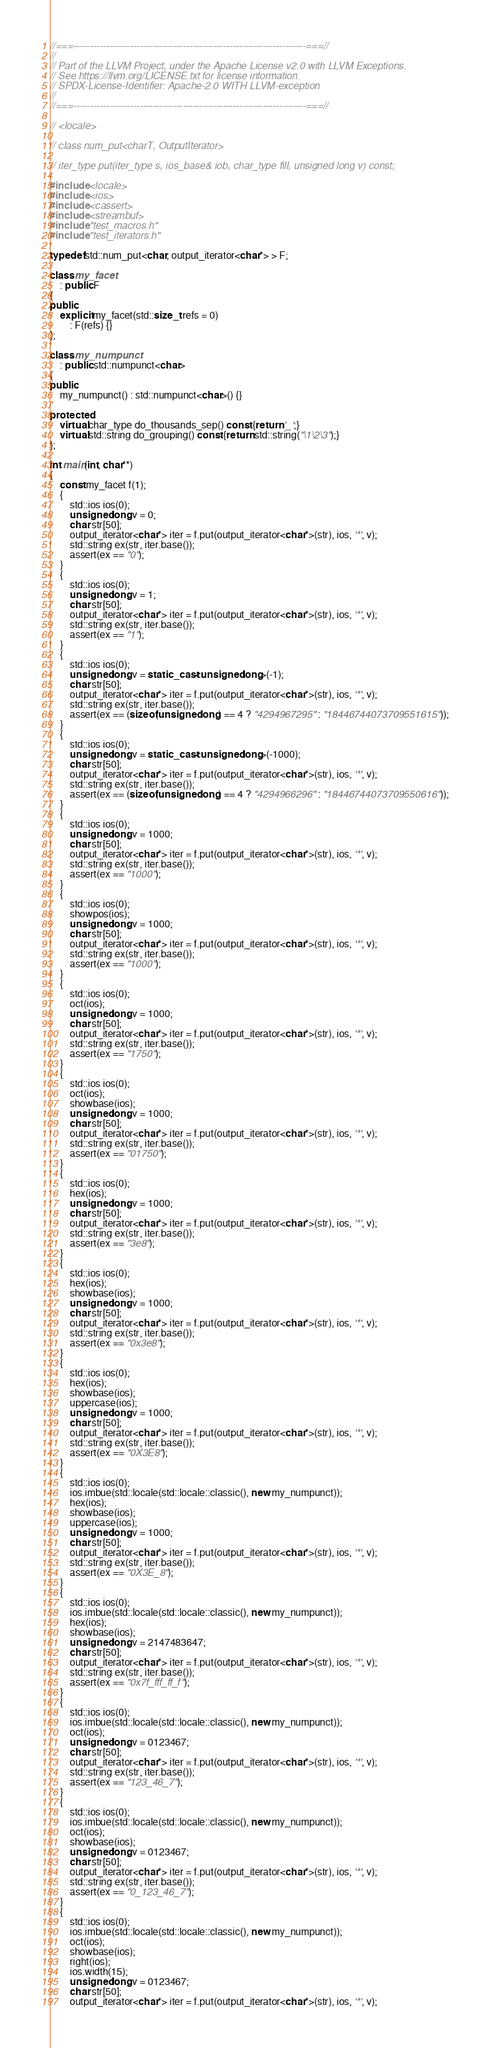<code> <loc_0><loc_0><loc_500><loc_500><_C++_>//===----------------------------------------------------------------------===//
//
// Part of the LLVM Project, under the Apache License v2.0 with LLVM Exceptions.
// See https://llvm.org/LICENSE.txt for license information.
// SPDX-License-Identifier: Apache-2.0 WITH LLVM-exception
//
//===----------------------------------------------------------------------===//

// <locale>

// class num_put<charT, OutputIterator>

// iter_type put(iter_type s, ios_base& iob, char_type fill, unsigned long v) const;

#include <locale>
#include <ios>
#include <cassert>
#include <streambuf>
#include "test_macros.h"
#include "test_iterators.h"

typedef std::num_put<char, output_iterator<char*> > F;

class my_facet
    : public F
{
public:
    explicit my_facet(std::size_t refs = 0)
        : F(refs) {}
};

class my_numpunct
    : public std::numpunct<char>
{
public:
    my_numpunct() : std::numpunct<char>() {}

protected:
    virtual char_type do_thousands_sep() const {return '_';}
    virtual std::string do_grouping() const {return std::string("\1\2\3");}
};

int main(int, char**)
{
    const my_facet f(1);
    {
        std::ios ios(0);
        unsigned long v = 0;
        char str[50];
        output_iterator<char*> iter = f.put(output_iterator<char*>(str), ios, '*', v);
        std::string ex(str, iter.base());
        assert(ex == "0");
    }
    {
        std::ios ios(0);
        unsigned long v = 1;
        char str[50];
        output_iterator<char*> iter = f.put(output_iterator<char*>(str), ios, '*', v);
        std::string ex(str, iter.base());
        assert(ex == "1");
    }
    {
        std::ios ios(0);
        unsigned long v = static_cast<unsigned long>(-1);
        char str[50];
        output_iterator<char*> iter = f.put(output_iterator<char*>(str), ios, '*', v);
        std::string ex(str, iter.base());
        assert(ex == (sizeof(unsigned long) == 4 ? "4294967295" : "18446744073709551615"));
    }
    {
        std::ios ios(0);
        unsigned long v = static_cast<unsigned long>(-1000);
        char str[50];
        output_iterator<char*> iter = f.put(output_iterator<char*>(str), ios, '*', v);
        std::string ex(str, iter.base());
        assert(ex == (sizeof(unsigned long) == 4 ? "4294966296" : "18446744073709550616"));
    }
    {
        std::ios ios(0);
        unsigned long v = 1000;
        char str[50];
        output_iterator<char*> iter = f.put(output_iterator<char*>(str), ios, '*', v);
        std::string ex(str, iter.base());
        assert(ex == "1000");
    }
    {
        std::ios ios(0);
        showpos(ios);
        unsigned long v = 1000;
        char str[50];
        output_iterator<char*> iter = f.put(output_iterator<char*>(str), ios, '*', v);
        std::string ex(str, iter.base());
        assert(ex == "1000");
    }
    {
        std::ios ios(0);
        oct(ios);
        unsigned long v = 1000;
        char str[50];
        output_iterator<char*> iter = f.put(output_iterator<char*>(str), ios, '*', v);
        std::string ex(str, iter.base());
        assert(ex == "1750");
    }
    {
        std::ios ios(0);
        oct(ios);
        showbase(ios);
        unsigned long v = 1000;
        char str[50];
        output_iterator<char*> iter = f.put(output_iterator<char*>(str), ios, '*', v);
        std::string ex(str, iter.base());
        assert(ex == "01750");
    }
    {
        std::ios ios(0);
        hex(ios);
        unsigned long v = 1000;
        char str[50];
        output_iterator<char*> iter = f.put(output_iterator<char*>(str), ios, '*', v);
        std::string ex(str, iter.base());
        assert(ex == "3e8");
    }
    {
        std::ios ios(0);
        hex(ios);
        showbase(ios);
        unsigned long v = 1000;
        char str[50];
        output_iterator<char*> iter = f.put(output_iterator<char*>(str), ios, '*', v);
        std::string ex(str, iter.base());
        assert(ex == "0x3e8");
    }
    {
        std::ios ios(0);
        hex(ios);
        showbase(ios);
        uppercase(ios);
        unsigned long v = 1000;
        char str[50];
        output_iterator<char*> iter = f.put(output_iterator<char*>(str), ios, '*', v);
        std::string ex(str, iter.base());
        assert(ex == "0X3E8");
    }
    {
        std::ios ios(0);
        ios.imbue(std::locale(std::locale::classic(), new my_numpunct));
        hex(ios);
        showbase(ios);
        uppercase(ios);
        unsigned long v = 1000;
        char str[50];
        output_iterator<char*> iter = f.put(output_iterator<char*>(str), ios, '*', v);
        std::string ex(str, iter.base());
        assert(ex == "0X3E_8");
    }
    {
        std::ios ios(0);
        ios.imbue(std::locale(std::locale::classic(), new my_numpunct));
        hex(ios);
        showbase(ios);
        unsigned long v = 2147483647;
        char str[50];
        output_iterator<char*> iter = f.put(output_iterator<char*>(str), ios, '*', v);
        std::string ex(str, iter.base());
        assert(ex == "0x7f_fff_ff_f");
    }
    {
        std::ios ios(0);
        ios.imbue(std::locale(std::locale::classic(), new my_numpunct));
        oct(ios);
        unsigned long v = 0123467;
        char str[50];
        output_iterator<char*> iter = f.put(output_iterator<char*>(str), ios, '*', v);
        std::string ex(str, iter.base());
        assert(ex == "123_46_7");
    }
    {
        std::ios ios(0);
        ios.imbue(std::locale(std::locale::classic(), new my_numpunct));
        oct(ios);
        showbase(ios);
        unsigned long v = 0123467;
        char str[50];
        output_iterator<char*> iter = f.put(output_iterator<char*>(str), ios, '*', v);
        std::string ex(str, iter.base());
        assert(ex == "0_123_46_7");
    }
    {
        std::ios ios(0);
        ios.imbue(std::locale(std::locale::classic(), new my_numpunct));
        oct(ios);
        showbase(ios);
        right(ios);
        ios.width(15);
        unsigned long v = 0123467;
        char str[50];
        output_iterator<char*> iter = f.put(output_iterator<char*>(str), ios, '*', v);</code> 